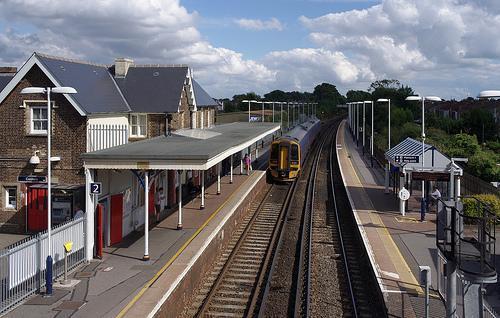How many trains are there?
Give a very brief answer. 1. 